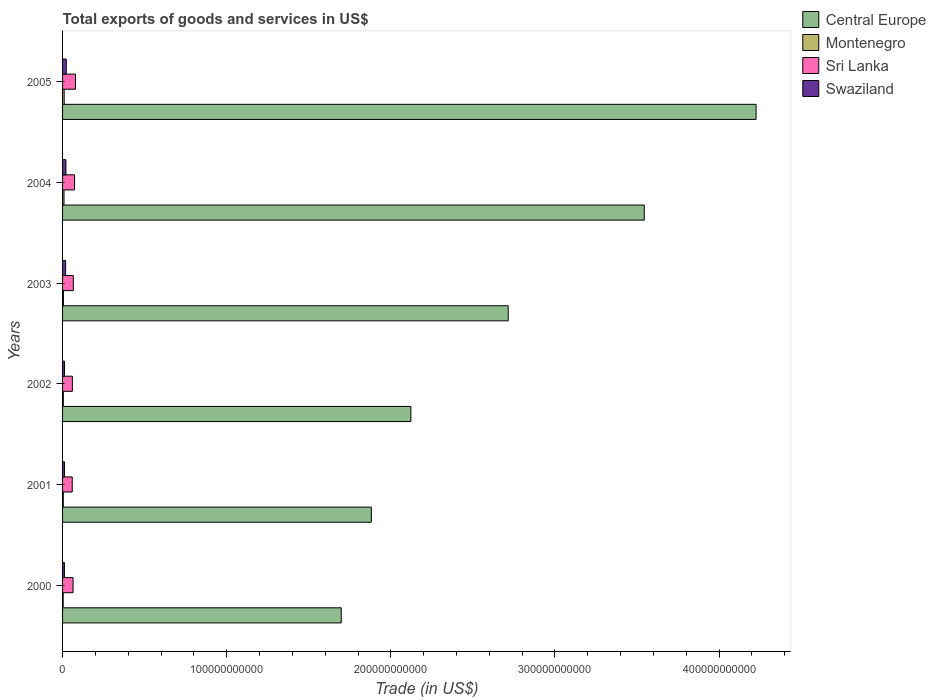How many groups of bars are there?
Your response must be concise. 6. Are the number of bars on each tick of the Y-axis equal?
Provide a succinct answer. Yes. What is the label of the 2nd group of bars from the top?
Provide a succinct answer. 2004. In how many cases, is the number of bars for a given year not equal to the number of legend labels?
Offer a terse response. 0. What is the total exports of goods and services in Sri Lanka in 2002?
Keep it short and to the point. 5.97e+09. Across all years, what is the maximum total exports of goods and services in Swaziland?
Your answer should be compact. 2.25e+09. Across all years, what is the minimum total exports of goods and services in Swaziland?
Give a very brief answer. 1.13e+09. In which year was the total exports of goods and services in Central Europe maximum?
Give a very brief answer. 2005. In which year was the total exports of goods and services in Sri Lanka minimum?
Make the answer very short. 2001. What is the total total exports of goods and services in Montenegro in the graph?
Make the answer very short. 3.64e+09. What is the difference between the total exports of goods and services in Swaziland in 2004 and that in 2005?
Offer a very short reply. -1.94e+08. What is the difference between the total exports of goods and services in Sri Lanka in 2001 and the total exports of goods and services in Swaziland in 2003?
Your response must be concise. 4.01e+09. What is the average total exports of goods and services in Sri Lanka per year?
Your answer should be compact. 6.66e+09. In the year 2003, what is the difference between the total exports of goods and services in Montenegro and total exports of goods and services in Central Europe?
Keep it short and to the point. -2.71e+11. In how many years, is the total exports of goods and services in Central Europe greater than 140000000000 US$?
Your answer should be very brief. 6. What is the ratio of the total exports of goods and services in Swaziland in 2003 to that in 2005?
Provide a succinct answer. 0.83. What is the difference between the highest and the second highest total exports of goods and services in Central Europe?
Offer a terse response. 6.81e+1. What is the difference between the highest and the lowest total exports of goods and services in Swaziland?
Your answer should be compact. 1.12e+09. Is the sum of the total exports of goods and services in Central Europe in 2003 and 2005 greater than the maximum total exports of goods and services in Swaziland across all years?
Make the answer very short. Yes. What does the 4th bar from the top in 2005 represents?
Your response must be concise. Central Europe. What does the 3rd bar from the bottom in 2003 represents?
Provide a succinct answer. Sri Lanka. Is it the case that in every year, the sum of the total exports of goods and services in Sri Lanka and total exports of goods and services in Central Europe is greater than the total exports of goods and services in Montenegro?
Your answer should be very brief. Yes. How many bars are there?
Provide a succinct answer. 24. Are all the bars in the graph horizontal?
Your answer should be very brief. Yes. How many years are there in the graph?
Make the answer very short. 6. What is the difference between two consecutive major ticks on the X-axis?
Make the answer very short. 1.00e+11. Are the values on the major ticks of X-axis written in scientific E-notation?
Make the answer very short. No. Does the graph contain any zero values?
Your answer should be compact. No. Does the graph contain grids?
Offer a terse response. No. How many legend labels are there?
Keep it short and to the point. 4. What is the title of the graph?
Provide a short and direct response. Total exports of goods and services in US$. What is the label or title of the X-axis?
Provide a succinct answer. Trade (in US$). What is the label or title of the Y-axis?
Provide a succinct answer. Years. What is the Trade (in US$) of Central Europe in 2000?
Your answer should be compact. 1.70e+11. What is the Trade (in US$) in Montenegro in 2000?
Ensure brevity in your answer.  3.62e+08. What is the Trade (in US$) of Sri Lanka in 2000?
Your response must be concise. 6.37e+09. What is the Trade (in US$) of Swaziland in 2000?
Give a very brief answer. 1.13e+09. What is the Trade (in US$) of Central Europe in 2001?
Make the answer very short. 1.88e+11. What is the Trade (in US$) in Montenegro in 2001?
Offer a very short reply. 4.46e+08. What is the Trade (in US$) in Sri Lanka in 2001?
Offer a terse response. 5.88e+09. What is the Trade (in US$) in Swaziland in 2001?
Give a very brief answer. 1.15e+09. What is the Trade (in US$) in Central Europe in 2002?
Your response must be concise. 2.12e+11. What is the Trade (in US$) of Montenegro in 2002?
Offer a terse response. 4.54e+08. What is the Trade (in US$) of Sri Lanka in 2002?
Your answer should be compact. 5.97e+09. What is the Trade (in US$) of Swaziland in 2002?
Your answer should be compact. 1.17e+09. What is the Trade (in US$) of Central Europe in 2003?
Ensure brevity in your answer.  2.72e+11. What is the Trade (in US$) of Montenegro in 2003?
Provide a succinct answer. 5.23e+08. What is the Trade (in US$) in Sri Lanka in 2003?
Provide a succinct answer. 6.54e+09. What is the Trade (in US$) in Swaziland in 2003?
Keep it short and to the point. 1.87e+09. What is the Trade (in US$) of Central Europe in 2004?
Your answer should be very brief. 3.54e+11. What is the Trade (in US$) in Montenegro in 2004?
Keep it short and to the point. 8.71e+08. What is the Trade (in US$) of Sri Lanka in 2004?
Your answer should be very brief. 7.30e+09. What is the Trade (in US$) in Swaziland in 2004?
Your answer should be very brief. 2.06e+09. What is the Trade (in US$) of Central Europe in 2005?
Make the answer very short. 4.23e+11. What is the Trade (in US$) of Montenegro in 2005?
Offer a very short reply. 9.83e+08. What is the Trade (in US$) in Sri Lanka in 2005?
Your response must be concise. 7.89e+09. What is the Trade (in US$) in Swaziland in 2005?
Provide a short and direct response. 2.25e+09. Across all years, what is the maximum Trade (in US$) in Central Europe?
Your response must be concise. 4.23e+11. Across all years, what is the maximum Trade (in US$) in Montenegro?
Make the answer very short. 9.83e+08. Across all years, what is the maximum Trade (in US$) of Sri Lanka?
Keep it short and to the point. 7.89e+09. Across all years, what is the maximum Trade (in US$) in Swaziland?
Your response must be concise. 2.25e+09. Across all years, what is the minimum Trade (in US$) in Central Europe?
Ensure brevity in your answer.  1.70e+11. Across all years, what is the minimum Trade (in US$) of Montenegro?
Make the answer very short. 3.62e+08. Across all years, what is the minimum Trade (in US$) in Sri Lanka?
Provide a short and direct response. 5.88e+09. Across all years, what is the minimum Trade (in US$) in Swaziland?
Your response must be concise. 1.13e+09. What is the total Trade (in US$) in Central Europe in the graph?
Provide a short and direct response. 1.62e+12. What is the total Trade (in US$) of Montenegro in the graph?
Ensure brevity in your answer.  3.64e+09. What is the total Trade (in US$) of Sri Lanka in the graph?
Ensure brevity in your answer.  4.00e+1. What is the total Trade (in US$) of Swaziland in the graph?
Provide a succinct answer. 9.64e+09. What is the difference between the Trade (in US$) of Central Europe in 2000 and that in 2001?
Give a very brief answer. -1.83e+1. What is the difference between the Trade (in US$) in Montenegro in 2000 and that in 2001?
Make the answer very short. -8.33e+07. What is the difference between the Trade (in US$) in Sri Lanka in 2000 and that in 2001?
Offer a very short reply. 4.93e+08. What is the difference between the Trade (in US$) of Swaziland in 2000 and that in 2001?
Keep it short and to the point. -1.98e+07. What is the difference between the Trade (in US$) in Central Europe in 2000 and that in 2002?
Provide a short and direct response. -4.24e+1. What is the difference between the Trade (in US$) of Montenegro in 2000 and that in 2002?
Ensure brevity in your answer.  -9.19e+07. What is the difference between the Trade (in US$) of Sri Lanka in 2000 and that in 2002?
Keep it short and to the point. 4.00e+08. What is the difference between the Trade (in US$) of Swaziland in 2000 and that in 2002?
Keep it short and to the point. -3.86e+07. What is the difference between the Trade (in US$) in Central Europe in 2000 and that in 2003?
Your answer should be very brief. -1.02e+11. What is the difference between the Trade (in US$) of Montenegro in 2000 and that in 2003?
Provide a succinct answer. -1.60e+08. What is the difference between the Trade (in US$) of Sri Lanka in 2000 and that in 2003?
Offer a very short reply. -1.72e+08. What is the difference between the Trade (in US$) of Swaziland in 2000 and that in 2003?
Provide a short and direct response. -7.39e+08. What is the difference between the Trade (in US$) in Central Europe in 2000 and that in 2004?
Give a very brief answer. -1.85e+11. What is the difference between the Trade (in US$) in Montenegro in 2000 and that in 2004?
Keep it short and to the point. -5.09e+08. What is the difference between the Trade (in US$) of Sri Lanka in 2000 and that in 2004?
Offer a very short reply. -9.29e+08. What is the difference between the Trade (in US$) in Swaziland in 2000 and that in 2004?
Give a very brief answer. -9.23e+08. What is the difference between the Trade (in US$) in Central Europe in 2000 and that in 2005?
Your answer should be very brief. -2.53e+11. What is the difference between the Trade (in US$) in Montenegro in 2000 and that in 2005?
Your response must be concise. -6.21e+08. What is the difference between the Trade (in US$) of Sri Lanka in 2000 and that in 2005?
Your answer should be compact. -1.52e+09. What is the difference between the Trade (in US$) of Swaziland in 2000 and that in 2005?
Ensure brevity in your answer.  -1.12e+09. What is the difference between the Trade (in US$) in Central Europe in 2001 and that in 2002?
Give a very brief answer. -2.41e+1. What is the difference between the Trade (in US$) in Montenegro in 2001 and that in 2002?
Ensure brevity in your answer.  -8.56e+06. What is the difference between the Trade (in US$) of Sri Lanka in 2001 and that in 2002?
Provide a succinct answer. -9.28e+07. What is the difference between the Trade (in US$) of Swaziland in 2001 and that in 2002?
Your answer should be very brief. -1.88e+07. What is the difference between the Trade (in US$) of Central Europe in 2001 and that in 2003?
Your response must be concise. -8.34e+1. What is the difference between the Trade (in US$) in Montenegro in 2001 and that in 2003?
Provide a short and direct response. -7.71e+07. What is the difference between the Trade (in US$) in Sri Lanka in 2001 and that in 2003?
Give a very brief answer. -6.65e+08. What is the difference between the Trade (in US$) of Swaziland in 2001 and that in 2003?
Provide a succinct answer. -7.19e+08. What is the difference between the Trade (in US$) in Central Europe in 2001 and that in 2004?
Ensure brevity in your answer.  -1.66e+11. What is the difference between the Trade (in US$) in Montenegro in 2001 and that in 2004?
Keep it short and to the point. -4.26e+08. What is the difference between the Trade (in US$) of Sri Lanka in 2001 and that in 2004?
Ensure brevity in your answer.  -1.42e+09. What is the difference between the Trade (in US$) in Swaziland in 2001 and that in 2004?
Your response must be concise. -9.03e+08. What is the difference between the Trade (in US$) in Central Europe in 2001 and that in 2005?
Ensure brevity in your answer.  -2.34e+11. What is the difference between the Trade (in US$) of Montenegro in 2001 and that in 2005?
Your answer should be very brief. -5.37e+08. What is the difference between the Trade (in US$) in Sri Lanka in 2001 and that in 2005?
Offer a terse response. -2.01e+09. What is the difference between the Trade (in US$) of Swaziland in 2001 and that in 2005?
Your response must be concise. -1.10e+09. What is the difference between the Trade (in US$) in Central Europe in 2002 and that in 2003?
Provide a short and direct response. -5.93e+1. What is the difference between the Trade (in US$) in Montenegro in 2002 and that in 2003?
Keep it short and to the point. -6.85e+07. What is the difference between the Trade (in US$) in Sri Lanka in 2002 and that in 2003?
Your answer should be compact. -5.72e+08. What is the difference between the Trade (in US$) of Swaziland in 2002 and that in 2003?
Your answer should be very brief. -7.00e+08. What is the difference between the Trade (in US$) of Central Europe in 2002 and that in 2004?
Your response must be concise. -1.42e+11. What is the difference between the Trade (in US$) of Montenegro in 2002 and that in 2004?
Your response must be concise. -4.17e+08. What is the difference between the Trade (in US$) of Sri Lanka in 2002 and that in 2004?
Your answer should be very brief. -1.33e+09. What is the difference between the Trade (in US$) of Swaziland in 2002 and that in 2004?
Offer a terse response. -8.84e+08. What is the difference between the Trade (in US$) in Central Europe in 2002 and that in 2005?
Give a very brief answer. -2.10e+11. What is the difference between the Trade (in US$) of Montenegro in 2002 and that in 2005?
Provide a short and direct response. -5.29e+08. What is the difference between the Trade (in US$) of Sri Lanka in 2002 and that in 2005?
Your response must be concise. -1.92e+09. What is the difference between the Trade (in US$) of Swaziland in 2002 and that in 2005?
Make the answer very short. -1.08e+09. What is the difference between the Trade (in US$) in Central Europe in 2003 and that in 2004?
Offer a very short reply. -8.29e+1. What is the difference between the Trade (in US$) of Montenegro in 2003 and that in 2004?
Your answer should be very brief. -3.48e+08. What is the difference between the Trade (in US$) in Sri Lanka in 2003 and that in 2004?
Ensure brevity in your answer.  -7.57e+08. What is the difference between the Trade (in US$) in Swaziland in 2003 and that in 2004?
Offer a terse response. -1.84e+08. What is the difference between the Trade (in US$) in Central Europe in 2003 and that in 2005?
Your answer should be very brief. -1.51e+11. What is the difference between the Trade (in US$) in Montenegro in 2003 and that in 2005?
Your answer should be very brief. -4.60e+08. What is the difference between the Trade (in US$) in Sri Lanka in 2003 and that in 2005?
Provide a succinct answer. -1.35e+09. What is the difference between the Trade (in US$) in Swaziland in 2003 and that in 2005?
Ensure brevity in your answer.  -3.78e+08. What is the difference between the Trade (in US$) in Central Europe in 2004 and that in 2005?
Offer a terse response. -6.81e+1. What is the difference between the Trade (in US$) of Montenegro in 2004 and that in 2005?
Make the answer very short. -1.12e+08. What is the difference between the Trade (in US$) in Sri Lanka in 2004 and that in 2005?
Offer a terse response. -5.92e+08. What is the difference between the Trade (in US$) in Swaziland in 2004 and that in 2005?
Offer a very short reply. -1.94e+08. What is the difference between the Trade (in US$) of Central Europe in 2000 and the Trade (in US$) of Montenegro in 2001?
Make the answer very short. 1.69e+11. What is the difference between the Trade (in US$) of Central Europe in 2000 and the Trade (in US$) of Sri Lanka in 2001?
Give a very brief answer. 1.64e+11. What is the difference between the Trade (in US$) of Central Europe in 2000 and the Trade (in US$) of Swaziland in 2001?
Your answer should be compact. 1.69e+11. What is the difference between the Trade (in US$) in Montenegro in 2000 and the Trade (in US$) in Sri Lanka in 2001?
Provide a short and direct response. -5.52e+09. What is the difference between the Trade (in US$) of Montenegro in 2000 and the Trade (in US$) of Swaziland in 2001?
Your answer should be compact. -7.91e+08. What is the difference between the Trade (in US$) in Sri Lanka in 2000 and the Trade (in US$) in Swaziland in 2001?
Your response must be concise. 5.22e+09. What is the difference between the Trade (in US$) of Central Europe in 2000 and the Trade (in US$) of Montenegro in 2002?
Make the answer very short. 1.69e+11. What is the difference between the Trade (in US$) of Central Europe in 2000 and the Trade (in US$) of Sri Lanka in 2002?
Make the answer very short. 1.64e+11. What is the difference between the Trade (in US$) in Central Europe in 2000 and the Trade (in US$) in Swaziland in 2002?
Provide a succinct answer. 1.69e+11. What is the difference between the Trade (in US$) in Montenegro in 2000 and the Trade (in US$) in Sri Lanka in 2002?
Offer a terse response. -5.61e+09. What is the difference between the Trade (in US$) of Montenegro in 2000 and the Trade (in US$) of Swaziland in 2002?
Give a very brief answer. -8.09e+08. What is the difference between the Trade (in US$) of Sri Lanka in 2000 and the Trade (in US$) of Swaziland in 2002?
Give a very brief answer. 5.20e+09. What is the difference between the Trade (in US$) in Central Europe in 2000 and the Trade (in US$) in Montenegro in 2003?
Make the answer very short. 1.69e+11. What is the difference between the Trade (in US$) in Central Europe in 2000 and the Trade (in US$) in Sri Lanka in 2003?
Make the answer very short. 1.63e+11. What is the difference between the Trade (in US$) in Central Europe in 2000 and the Trade (in US$) in Swaziland in 2003?
Make the answer very short. 1.68e+11. What is the difference between the Trade (in US$) of Montenegro in 2000 and the Trade (in US$) of Sri Lanka in 2003?
Keep it short and to the point. -6.18e+09. What is the difference between the Trade (in US$) of Montenegro in 2000 and the Trade (in US$) of Swaziland in 2003?
Keep it short and to the point. -1.51e+09. What is the difference between the Trade (in US$) of Sri Lanka in 2000 and the Trade (in US$) of Swaziland in 2003?
Your response must be concise. 4.50e+09. What is the difference between the Trade (in US$) of Central Europe in 2000 and the Trade (in US$) of Montenegro in 2004?
Your response must be concise. 1.69e+11. What is the difference between the Trade (in US$) of Central Europe in 2000 and the Trade (in US$) of Sri Lanka in 2004?
Provide a succinct answer. 1.62e+11. What is the difference between the Trade (in US$) in Central Europe in 2000 and the Trade (in US$) in Swaziland in 2004?
Make the answer very short. 1.68e+11. What is the difference between the Trade (in US$) in Montenegro in 2000 and the Trade (in US$) in Sri Lanka in 2004?
Keep it short and to the point. -6.94e+09. What is the difference between the Trade (in US$) of Montenegro in 2000 and the Trade (in US$) of Swaziland in 2004?
Offer a terse response. -1.69e+09. What is the difference between the Trade (in US$) in Sri Lanka in 2000 and the Trade (in US$) in Swaziland in 2004?
Your response must be concise. 4.32e+09. What is the difference between the Trade (in US$) of Central Europe in 2000 and the Trade (in US$) of Montenegro in 2005?
Keep it short and to the point. 1.69e+11. What is the difference between the Trade (in US$) in Central Europe in 2000 and the Trade (in US$) in Sri Lanka in 2005?
Make the answer very short. 1.62e+11. What is the difference between the Trade (in US$) of Central Europe in 2000 and the Trade (in US$) of Swaziland in 2005?
Your answer should be very brief. 1.68e+11. What is the difference between the Trade (in US$) in Montenegro in 2000 and the Trade (in US$) in Sri Lanka in 2005?
Keep it short and to the point. -7.53e+09. What is the difference between the Trade (in US$) in Montenegro in 2000 and the Trade (in US$) in Swaziland in 2005?
Offer a very short reply. -1.89e+09. What is the difference between the Trade (in US$) in Sri Lanka in 2000 and the Trade (in US$) in Swaziland in 2005?
Give a very brief answer. 4.12e+09. What is the difference between the Trade (in US$) of Central Europe in 2001 and the Trade (in US$) of Montenegro in 2002?
Your answer should be very brief. 1.88e+11. What is the difference between the Trade (in US$) in Central Europe in 2001 and the Trade (in US$) in Sri Lanka in 2002?
Your answer should be very brief. 1.82e+11. What is the difference between the Trade (in US$) in Central Europe in 2001 and the Trade (in US$) in Swaziland in 2002?
Ensure brevity in your answer.  1.87e+11. What is the difference between the Trade (in US$) of Montenegro in 2001 and the Trade (in US$) of Sri Lanka in 2002?
Make the answer very short. -5.53e+09. What is the difference between the Trade (in US$) in Montenegro in 2001 and the Trade (in US$) in Swaziland in 2002?
Make the answer very short. -7.26e+08. What is the difference between the Trade (in US$) in Sri Lanka in 2001 and the Trade (in US$) in Swaziland in 2002?
Your answer should be compact. 4.71e+09. What is the difference between the Trade (in US$) in Central Europe in 2001 and the Trade (in US$) in Montenegro in 2003?
Give a very brief answer. 1.88e+11. What is the difference between the Trade (in US$) of Central Europe in 2001 and the Trade (in US$) of Sri Lanka in 2003?
Your answer should be compact. 1.82e+11. What is the difference between the Trade (in US$) of Central Europe in 2001 and the Trade (in US$) of Swaziland in 2003?
Make the answer very short. 1.86e+11. What is the difference between the Trade (in US$) of Montenegro in 2001 and the Trade (in US$) of Sri Lanka in 2003?
Your answer should be very brief. -6.10e+09. What is the difference between the Trade (in US$) in Montenegro in 2001 and the Trade (in US$) in Swaziland in 2003?
Give a very brief answer. -1.43e+09. What is the difference between the Trade (in US$) in Sri Lanka in 2001 and the Trade (in US$) in Swaziland in 2003?
Make the answer very short. 4.01e+09. What is the difference between the Trade (in US$) in Central Europe in 2001 and the Trade (in US$) in Montenegro in 2004?
Provide a short and direct response. 1.87e+11. What is the difference between the Trade (in US$) of Central Europe in 2001 and the Trade (in US$) of Sri Lanka in 2004?
Provide a succinct answer. 1.81e+11. What is the difference between the Trade (in US$) in Central Europe in 2001 and the Trade (in US$) in Swaziland in 2004?
Ensure brevity in your answer.  1.86e+11. What is the difference between the Trade (in US$) of Montenegro in 2001 and the Trade (in US$) of Sri Lanka in 2004?
Keep it short and to the point. -6.85e+09. What is the difference between the Trade (in US$) of Montenegro in 2001 and the Trade (in US$) of Swaziland in 2004?
Offer a very short reply. -1.61e+09. What is the difference between the Trade (in US$) in Sri Lanka in 2001 and the Trade (in US$) in Swaziland in 2004?
Provide a short and direct response. 3.82e+09. What is the difference between the Trade (in US$) of Central Europe in 2001 and the Trade (in US$) of Montenegro in 2005?
Ensure brevity in your answer.  1.87e+11. What is the difference between the Trade (in US$) of Central Europe in 2001 and the Trade (in US$) of Sri Lanka in 2005?
Offer a very short reply. 1.80e+11. What is the difference between the Trade (in US$) in Central Europe in 2001 and the Trade (in US$) in Swaziland in 2005?
Give a very brief answer. 1.86e+11. What is the difference between the Trade (in US$) in Montenegro in 2001 and the Trade (in US$) in Sri Lanka in 2005?
Offer a very short reply. -7.45e+09. What is the difference between the Trade (in US$) of Montenegro in 2001 and the Trade (in US$) of Swaziland in 2005?
Your answer should be very brief. -1.80e+09. What is the difference between the Trade (in US$) in Sri Lanka in 2001 and the Trade (in US$) in Swaziland in 2005?
Offer a very short reply. 3.63e+09. What is the difference between the Trade (in US$) in Central Europe in 2002 and the Trade (in US$) in Montenegro in 2003?
Your response must be concise. 2.12e+11. What is the difference between the Trade (in US$) in Central Europe in 2002 and the Trade (in US$) in Sri Lanka in 2003?
Make the answer very short. 2.06e+11. What is the difference between the Trade (in US$) of Central Europe in 2002 and the Trade (in US$) of Swaziland in 2003?
Make the answer very short. 2.10e+11. What is the difference between the Trade (in US$) of Montenegro in 2002 and the Trade (in US$) of Sri Lanka in 2003?
Keep it short and to the point. -6.09e+09. What is the difference between the Trade (in US$) of Montenegro in 2002 and the Trade (in US$) of Swaziland in 2003?
Your response must be concise. -1.42e+09. What is the difference between the Trade (in US$) in Sri Lanka in 2002 and the Trade (in US$) in Swaziland in 2003?
Provide a short and direct response. 4.10e+09. What is the difference between the Trade (in US$) in Central Europe in 2002 and the Trade (in US$) in Montenegro in 2004?
Your answer should be compact. 2.11e+11. What is the difference between the Trade (in US$) of Central Europe in 2002 and the Trade (in US$) of Sri Lanka in 2004?
Your response must be concise. 2.05e+11. What is the difference between the Trade (in US$) in Central Europe in 2002 and the Trade (in US$) in Swaziland in 2004?
Give a very brief answer. 2.10e+11. What is the difference between the Trade (in US$) of Montenegro in 2002 and the Trade (in US$) of Sri Lanka in 2004?
Give a very brief answer. -6.85e+09. What is the difference between the Trade (in US$) in Montenegro in 2002 and the Trade (in US$) in Swaziland in 2004?
Keep it short and to the point. -1.60e+09. What is the difference between the Trade (in US$) in Sri Lanka in 2002 and the Trade (in US$) in Swaziland in 2004?
Your response must be concise. 3.92e+09. What is the difference between the Trade (in US$) of Central Europe in 2002 and the Trade (in US$) of Montenegro in 2005?
Give a very brief answer. 2.11e+11. What is the difference between the Trade (in US$) of Central Europe in 2002 and the Trade (in US$) of Sri Lanka in 2005?
Your response must be concise. 2.04e+11. What is the difference between the Trade (in US$) in Central Europe in 2002 and the Trade (in US$) in Swaziland in 2005?
Provide a succinct answer. 2.10e+11. What is the difference between the Trade (in US$) in Montenegro in 2002 and the Trade (in US$) in Sri Lanka in 2005?
Give a very brief answer. -7.44e+09. What is the difference between the Trade (in US$) of Montenegro in 2002 and the Trade (in US$) of Swaziland in 2005?
Your response must be concise. -1.80e+09. What is the difference between the Trade (in US$) in Sri Lanka in 2002 and the Trade (in US$) in Swaziland in 2005?
Your answer should be very brief. 3.72e+09. What is the difference between the Trade (in US$) of Central Europe in 2003 and the Trade (in US$) of Montenegro in 2004?
Make the answer very short. 2.71e+11. What is the difference between the Trade (in US$) in Central Europe in 2003 and the Trade (in US$) in Sri Lanka in 2004?
Give a very brief answer. 2.64e+11. What is the difference between the Trade (in US$) in Central Europe in 2003 and the Trade (in US$) in Swaziland in 2004?
Offer a terse response. 2.69e+11. What is the difference between the Trade (in US$) of Montenegro in 2003 and the Trade (in US$) of Sri Lanka in 2004?
Offer a very short reply. -6.78e+09. What is the difference between the Trade (in US$) of Montenegro in 2003 and the Trade (in US$) of Swaziland in 2004?
Offer a very short reply. -1.53e+09. What is the difference between the Trade (in US$) in Sri Lanka in 2003 and the Trade (in US$) in Swaziland in 2004?
Keep it short and to the point. 4.49e+09. What is the difference between the Trade (in US$) in Central Europe in 2003 and the Trade (in US$) in Montenegro in 2005?
Offer a very short reply. 2.71e+11. What is the difference between the Trade (in US$) of Central Europe in 2003 and the Trade (in US$) of Sri Lanka in 2005?
Ensure brevity in your answer.  2.64e+11. What is the difference between the Trade (in US$) in Central Europe in 2003 and the Trade (in US$) in Swaziland in 2005?
Give a very brief answer. 2.69e+11. What is the difference between the Trade (in US$) in Montenegro in 2003 and the Trade (in US$) in Sri Lanka in 2005?
Offer a terse response. -7.37e+09. What is the difference between the Trade (in US$) in Montenegro in 2003 and the Trade (in US$) in Swaziland in 2005?
Your answer should be very brief. -1.73e+09. What is the difference between the Trade (in US$) in Sri Lanka in 2003 and the Trade (in US$) in Swaziland in 2005?
Ensure brevity in your answer.  4.29e+09. What is the difference between the Trade (in US$) in Central Europe in 2004 and the Trade (in US$) in Montenegro in 2005?
Offer a terse response. 3.53e+11. What is the difference between the Trade (in US$) in Central Europe in 2004 and the Trade (in US$) in Sri Lanka in 2005?
Your response must be concise. 3.47e+11. What is the difference between the Trade (in US$) in Central Europe in 2004 and the Trade (in US$) in Swaziland in 2005?
Your response must be concise. 3.52e+11. What is the difference between the Trade (in US$) of Montenegro in 2004 and the Trade (in US$) of Sri Lanka in 2005?
Make the answer very short. -7.02e+09. What is the difference between the Trade (in US$) of Montenegro in 2004 and the Trade (in US$) of Swaziland in 2005?
Give a very brief answer. -1.38e+09. What is the difference between the Trade (in US$) of Sri Lanka in 2004 and the Trade (in US$) of Swaziland in 2005?
Your answer should be compact. 5.05e+09. What is the average Trade (in US$) in Central Europe per year?
Make the answer very short. 2.70e+11. What is the average Trade (in US$) in Montenegro per year?
Offer a terse response. 6.07e+08. What is the average Trade (in US$) in Sri Lanka per year?
Your answer should be very brief. 6.66e+09. What is the average Trade (in US$) of Swaziland per year?
Your answer should be compact. 1.61e+09. In the year 2000, what is the difference between the Trade (in US$) in Central Europe and Trade (in US$) in Montenegro?
Offer a terse response. 1.69e+11. In the year 2000, what is the difference between the Trade (in US$) of Central Europe and Trade (in US$) of Sri Lanka?
Give a very brief answer. 1.63e+11. In the year 2000, what is the difference between the Trade (in US$) of Central Europe and Trade (in US$) of Swaziland?
Your answer should be compact. 1.69e+11. In the year 2000, what is the difference between the Trade (in US$) in Montenegro and Trade (in US$) in Sri Lanka?
Your answer should be compact. -6.01e+09. In the year 2000, what is the difference between the Trade (in US$) in Montenegro and Trade (in US$) in Swaziland?
Give a very brief answer. -7.71e+08. In the year 2000, what is the difference between the Trade (in US$) in Sri Lanka and Trade (in US$) in Swaziland?
Your response must be concise. 5.24e+09. In the year 2001, what is the difference between the Trade (in US$) of Central Europe and Trade (in US$) of Montenegro?
Keep it short and to the point. 1.88e+11. In the year 2001, what is the difference between the Trade (in US$) of Central Europe and Trade (in US$) of Sri Lanka?
Offer a very short reply. 1.82e+11. In the year 2001, what is the difference between the Trade (in US$) in Central Europe and Trade (in US$) in Swaziland?
Your response must be concise. 1.87e+11. In the year 2001, what is the difference between the Trade (in US$) of Montenegro and Trade (in US$) of Sri Lanka?
Keep it short and to the point. -5.43e+09. In the year 2001, what is the difference between the Trade (in US$) in Montenegro and Trade (in US$) in Swaziland?
Your response must be concise. -7.07e+08. In the year 2001, what is the difference between the Trade (in US$) of Sri Lanka and Trade (in US$) of Swaziland?
Offer a terse response. 4.73e+09. In the year 2002, what is the difference between the Trade (in US$) in Central Europe and Trade (in US$) in Montenegro?
Provide a succinct answer. 2.12e+11. In the year 2002, what is the difference between the Trade (in US$) of Central Europe and Trade (in US$) of Sri Lanka?
Your answer should be compact. 2.06e+11. In the year 2002, what is the difference between the Trade (in US$) in Central Europe and Trade (in US$) in Swaziland?
Your answer should be compact. 2.11e+11. In the year 2002, what is the difference between the Trade (in US$) of Montenegro and Trade (in US$) of Sri Lanka?
Provide a succinct answer. -5.52e+09. In the year 2002, what is the difference between the Trade (in US$) in Montenegro and Trade (in US$) in Swaziland?
Your answer should be very brief. -7.17e+08. In the year 2002, what is the difference between the Trade (in US$) of Sri Lanka and Trade (in US$) of Swaziland?
Offer a very short reply. 4.80e+09. In the year 2003, what is the difference between the Trade (in US$) in Central Europe and Trade (in US$) in Montenegro?
Provide a succinct answer. 2.71e+11. In the year 2003, what is the difference between the Trade (in US$) of Central Europe and Trade (in US$) of Sri Lanka?
Your answer should be compact. 2.65e+11. In the year 2003, what is the difference between the Trade (in US$) of Central Europe and Trade (in US$) of Swaziland?
Your answer should be very brief. 2.70e+11. In the year 2003, what is the difference between the Trade (in US$) of Montenegro and Trade (in US$) of Sri Lanka?
Offer a terse response. -6.02e+09. In the year 2003, what is the difference between the Trade (in US$) in Montenegro and Trade (in US$) in Swaziland?
Provide a short and direct response. -1.35e+09. In the year 2003, what is the difference between the Trade (in US$) of Sri Lanka and Trade (in US$) of Swaziland?
Ensure brevity in your answer.  4.67e+09. In the year 2004, what is the difference between the Trade (in US$) of Central Europe and Trade (in US$) of Montenegro?
Your answer should be compact. 3.54e+11. In the year 2004, what is the difference between the Trade (in US$) in Central Europe and Trade (in US$) in Sri Lanka?
Your answer should be compact. 3.47e+11. In the year 2004, what is the difference between the Trade (in US$) of Central Europe and Trade (in US$) of Swaziland?
Provide a succinct answer. 3.52e+11. In the year 2004, what is the difference between the Trade (in US$) of Montenegro and Trade (in US$) of Sri Lanka?
Make the answer very short. -6.43e+09. In the year 2004, what is the difference between the Trade (in US$) of Montenegro and Trade (in US$) of Swaziland?
Ensure brevity in your answer.  -1.18e+09. In the year 2004, what is the difference between the Trade (in US$) of Sri Lanka and Trade (in US$) of Swaziland?
Provide a succinct answer. 5.24e+09. In the year 2005, what is the difference between the Trade (in US$) of Central Europe and Trade (in US$) of Montenegro?
Give a very brief answer. 4.22e+11. In the year 2005, what is the difference between the Trade (in US$) of Central Europe and Trade (in US$) of Sri Lanka?
Keep it short and to the point. 4.15e+11. In the year 2005, what is the difference between the Trade (in US$) of Central Europe and Trade (in US$) of Swaziland?
Keep it short and to the point. 4.20e+11. In the year 2005, what is the difference between the Trade (in US$) of Montenegro and Trade (in US$) of Sri Lanka?
Provide a succinct answer. -6.91e+09. In the year 2005, what is the difference between the Trade (in US$) in Montenegro and Trade (in US$) in Swaziland?
Ensure brevity in your answer.  -1.27e+09. In the year 2005, what is the difference between the Trade (in US$) of Sri Lanka and Trade (in US$) of Swaziland?
Your answer should be compact. 5.64e+09. What is the ratio of the Trade (in US$) of Central Europe in 2000 to that in 2001?
Your answer should be compact. 0.9. What is the ratio of the Trade (in US$) in Montenegro in 2000 to that in 2001?
Offer a terse response. 0.81. What is the ratio of the Trade (in US$) of Sri Lanka in 2000 to that in 2001?
Ensure brevity in your answer.  1.08. What is the ratio of the Trade (in US$) in Swaziland in 2000 to that in 2001?
Your response must be concise. 0.98. What is the ratio of the Trade (in US$) of Central Europe in 2000 to that in 2002?
Offer a terse response. 0.8. What is the ratio of the Trade (in US$) in Montenegro in 2000 to that in 2002?
Provide a succinct answer. 0.8. What is the ratio of the Trade (in US$) in Sri Lanka in 2000 to that in 2002?
Give a very brief answer. 1.07. What is the ratio of the Trade (in US$) of Central Europe in 2000 to that in 2003?
Offer a terse response. 0.63. What is the ratio of the Trade (in US$) in Montenegro in 2000 to that in 2003?
Your answer should be compact. 0.69. What is the ratio of the Trade (in US$) in Sri Lanka in 2000 to that in 2003?
Keep it short and to the point. 0.97. What is the ratio of the Trade (in US$) of Swaziland in 2000 to that in 2003?
Make the answer very short. 0.61. What is the ratio of the Trade (in US$) in Central Europe in 2000 to that in 2004?
Ensure brevity in your answer.  0.48. What is the ratio of the Trade (in US$) in Montenegro in 2000 to that in 2004?
Your answer should be very brief. 0.42. What is the ratio of the Trade (in US$) of Sri Lanka in 2000 to that in 2004?
Offer a terse response. 0.87. What is the ratio of the Trade (in US$) in Swaziland in 2000 to that in 2004?
Make the answer very short. 0.55. What is the ratio of the Trade (in US$) in Central Europe in 2000 to that in 2005?
Make the answer very short. 0.4. What is the ratio of the Trade (in US$) of Montenegro in 2000 to that in 2005?
Make the answer very short. 0.37. What is the ratio of the Trade (in US$) in Sri Lanka in 2000 to that in 2005?
Your response must be concise. 0.81. What is the ratio of the Trade (in US$) in Swaziland in 2000 to that in 2005?
Your answer should be very brief. 0.5. What is the ratio of the Trade (in US$) in Central Europe in 2001 to that in 2002?
Your answer should be very brief. 0.89. What is the ratio of the Trade (in US$) of Montenegro in 2001 to that in 2002?
Ensure brevity in your answer.  0.98. What is the ratio of the Trade (in US$) of Sri Lanka in 2001 to that in 2002?
Provide a short and direct response. 0.98. What is the ratio of the Trade (in US$) in Swaziland in 2001 to that in 2002?
Make the answer very short. 0.98. What is the ratio of the Trade (in US$) of Central Europe in 2001 to that in 2003?
Give a very brief answer. 0.69. What is the ratio of the Trade (in US$) of Montenegro in 2001 to that in 2003?
Ensure brevity in your answer.  0.85. What is the ratio of the Trade (in US$) of Sri Lanka in 2001 to that in 2003?
Your answer should be compact. 0.9. What is the ratio of the Trade (in US$) in Swaziland in 2001 to that in 2003?
Offer a terse response. 0.62. What is the ratio of the Trade (in US$) of Central Europe in 2001 to that in 2004?
Provide a short and direct response. 0.53. What is the ratio of the Trade (in US$) of Montenegro in 2001 to that in 2004?
Your response must be concise. 0.51. What is the ratio of the Trade (in US$) of Sri Lanka in 2001 to that in 2004?
Provide a succinct answer. 0.81. What is the ratio of the Trade (in US$) of Swaziland in 2001 to that in 2004?
Keep it short and to the point. 0.56. What is the ratio of the Trade (in US$) in Central Europe in 2001 to that in 2005?
Your response must be concise. 0.45. What is the ratio of the Trade (in US$) in Montenegro in 2001 to that in 2005?
Your answer should be compact. 0.45. What is the ratio of the Trade (in US$) of Sri Lanka in 2001 to that in 2005?
Your response must be concise. 0.74. What is the ratio of the Trade (in US$) in Swaziland in 2001 to that in 2005?
Provide a succinct answer. 0.51. What is the ratio of the Trade (in US$) in Central Europe in 2002 to that in 2003?
Your answer should be very brief. 0.78. What is the ratio of the Trade (in US$) in Montenegro in 2002 to that in 2003?
Your response must be concise. 0.87. What is the ratio of the Trade (in US$) of Sri Lanka in 2002 to that in 2003?
Your answer should be very brief. 0.91. What is the ratio of the Trade (in US$) of Swaziland in 2002 to that in 2003?
Offer a terse response. 0.63. What is the ratio of the Trade (in US$) in Central Europe in 2002 to that in 2004?
Make the answer very short. 0.6. What is the ratio of the Trade (in US$) in Montenegro in 2002 to that in 2004?
Keep it short and to the point. 0.52. What is the ratio of the Trade (in US$) of Sri Lanka in 2002 to that in 2004?
Provide a short and direct response. 0.82. What is the ratio of the Trade (in US$) in Swaziland in 2002 to that in 2004?
Your answer should be compact. 0.57. What is the ratio of the Trade (in US$) in Central Europe in 2002 to that in 2005?
Provide a succinct answer. 0.5. What is the ratio of the Trade (in US$) in Montenegro in 2002 to that in 2005?
Offer a very short reply. 0.46. What is the ratio of the Trade (in US$) of Sri Lanka in 2002 to that in 2005?
Provide a succinct answer. 0.76. What is the ratio of the Trade (in US$) in Swaziland in 2002 to that in 2005?
Offer a very short reply. 0.52. What is the ratio of the Trade (in US$) in Central Europe in 2003 to that in 2004?
Your response must be concise. 0.77. What is the ratio of the Trade (in US$) of Montenegro in 2003 to that in 2004?
Your response must be concise. 0.6. What is the ratio of the Trade (in US$) of Sri Lanka in 2003 to that in 2004?
Give a very brief answer. 0.9. What is the ratio of the Trade (in US$) in Swaziland in 2003 to that in 2004?
Ensure brevity in your answer.  0.91. What is the ratio of the Trade (in US$) of Central Europe in 2003 to that in 2005?
Ensure brevity in your answer.  0.64. What is the ratio of the Trade (in US$) of Montenegro in 2003 to that in 2005?
Give a very brief answer. 0.53. What is the ratio of the Trade (in US$) in Sri Lanka in 2003 to that in 2005?
Your answer should be very brief. 0.83. What is the ratio of the Trade (in US$) in Swaziland in 2003 to that in 2005?
Provide a succinct answer. 0.83. What is the ratio of the Trade (in US$) in Central Europe in 2004 to that in 2005?
Give a very brief answer. 0.84. What is the ratio of the Trade (in US$) in Montenegro in 2004 to that in 2005?
Your response must be concise. 0.89. What is the ratio of the Trade (in US$) in Sri Lanka in 2004 to that in 2005?
Your answer should be compact. 0.93. What is the ratio of the Trade (in US$) in Swaziland in 2004 to that in 2005?
Your answer should be very brief. 0.91. What is the difference between the highest and the second highest Trade (in US$) in Central Europe?
Your answer should be compact. 6.81e+1. What is the difference between the highest and the second highest Trade (in US$) of Montenegro?
Ensure brevity in your answer.  1.12e+08. What is the difference between the highest and the second highest Trade (in US$) of Sri Lanka?
Your answer should be very brief. 5.92e+08. What is the difference between the highest and the second highest Trade (in US$) of Swaziland?
Your answer should be very brief. 1.94e+08. What is the difference between the highest and the lowest Trade (in US$) in Central Europe?
Provide a short and direct response. 2.53e+11. What is the difference between the highest and the lowest Trade (in US$) in Montenegro?
Provide a short and direct response. 6.21e+08. What is the difference between the highest and the lowest Trade (in US$) in Sri Lanka?
Your answer should be very brief. 2.01e+09. What is the difference between the highest and the lowest Trade (in US$) of Swaziland?
Your answer should be very brief. 1.12e+09. 